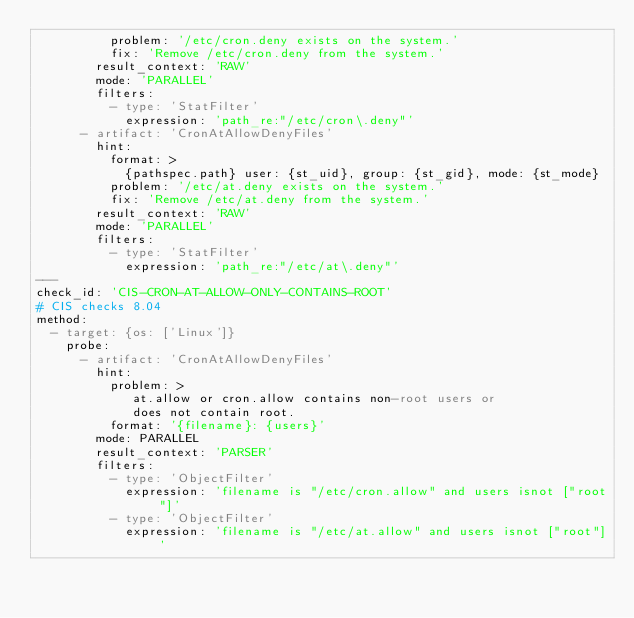Convert code to text. <code><loc_0><loc_0><loc_500><loc_500><_YAML_>          problem: '/etc/cron.deny exists on the system.'
          fix: 'Remove /etc/cron.deny from the system.'
        result_context: 'RAW'
        mode: 'PARALLEL'
        filters:
          - type: 'StatFilter'
            expression: 'path_re:"/etc/cron\.deny"'
      - artifact: 'CronAtAllowDenyFiles'
        hint:
          format: >
            {pathspec.path} user: {st_uid}, group: {st_gid}, mode: {st_mode}
          problem: '/etc/at.deny exists on the system.'
          fix: 'Remove /etc/at.deny from the system.'
        result_context: 'RAW'
        mode: 'PARALLEL'
        filters:
          - type: 'StatFilter'
            expression: 'path_re:"/etc/at\.deny"'
---
check_id: 'CIS-CRON-AT-ALLOW-ONLY-CONTAINS-ROOT'
# CIS checks 8.04
method:
  - target: {os: ['Linux']}
    probe:
      - artifact: 'CronAtAllowDenyFiles'
        hint:
          problem: >
             at.allow or cron.allow contains non-root users or
             does not contain root.
          format: '{filename}: {users}'
        mode: PARALLEL
        result_context: 'PARSER'
        filters:
          - type: 'ObjectFilter'
            expression: 'filename is "/etc/cron.allow" and users isnot ["root"]'
          - type: 'ObjectFilter'
            expression: 'filename is "/etc/at.allow" and users isnot ["root"]'
</code> 